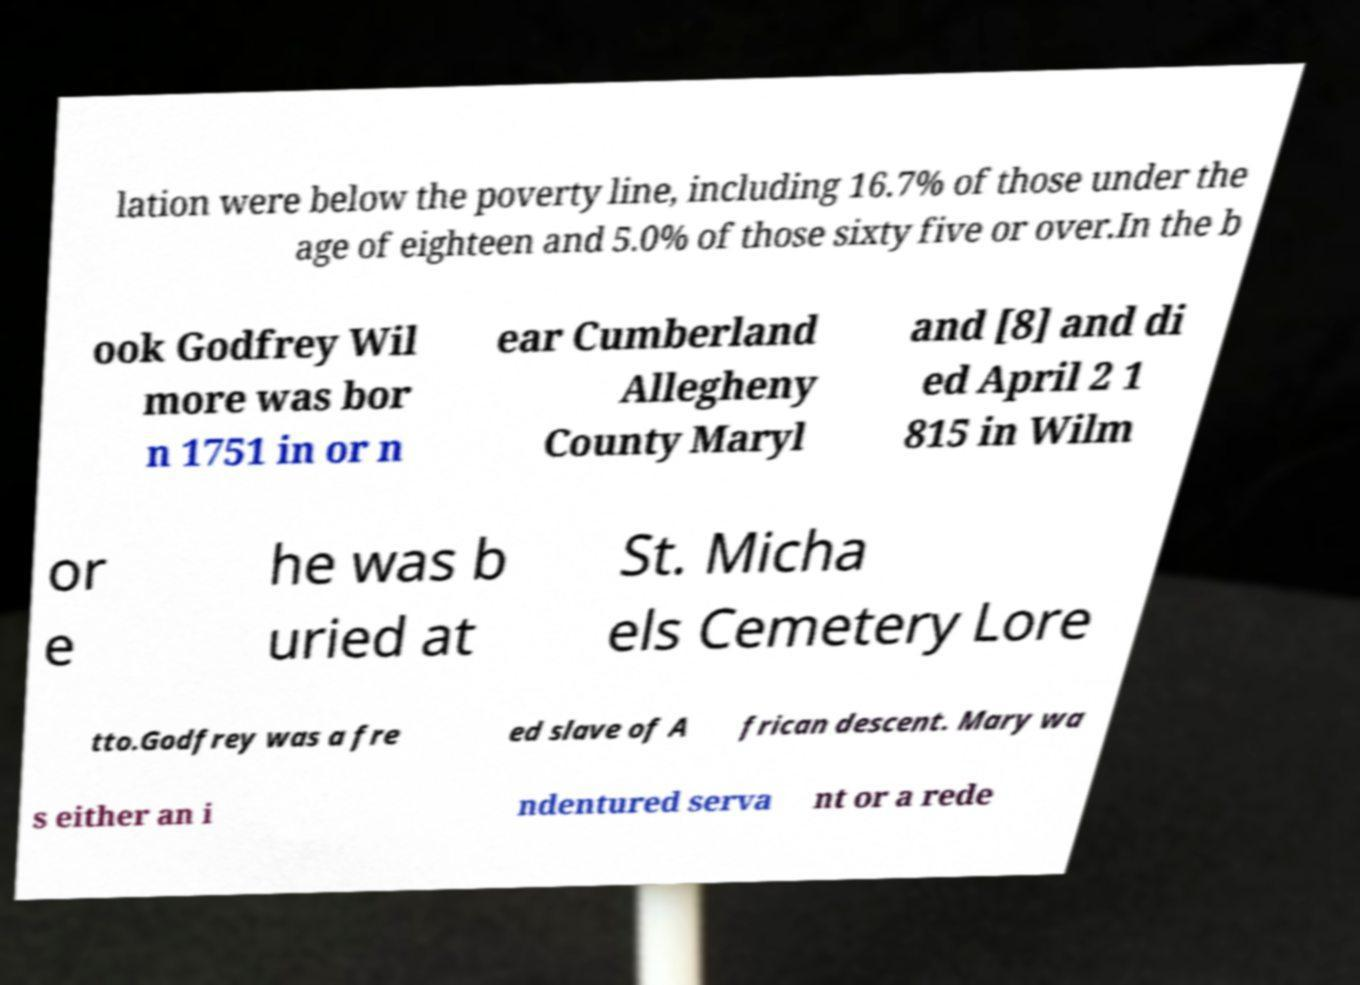There's text embedded in this image that I need extracted. Can you transcribe it verbatim? lation were below the poverty line, including 16.7% of those under the age of eighteen and 5.0% of those sixty five or over.In the b ook Godfrey Wil more was bor n 1751 in or n ear Cumberland Allegheny County Maryl and [8] and di ed April 2 1 815 in Wilm or e he was b uried at St. Micha els Cemetery Lore tto.Godfrey was a fre ed slave of A frican descent. Mary wa s either an i ndentured serva nt or a rede 